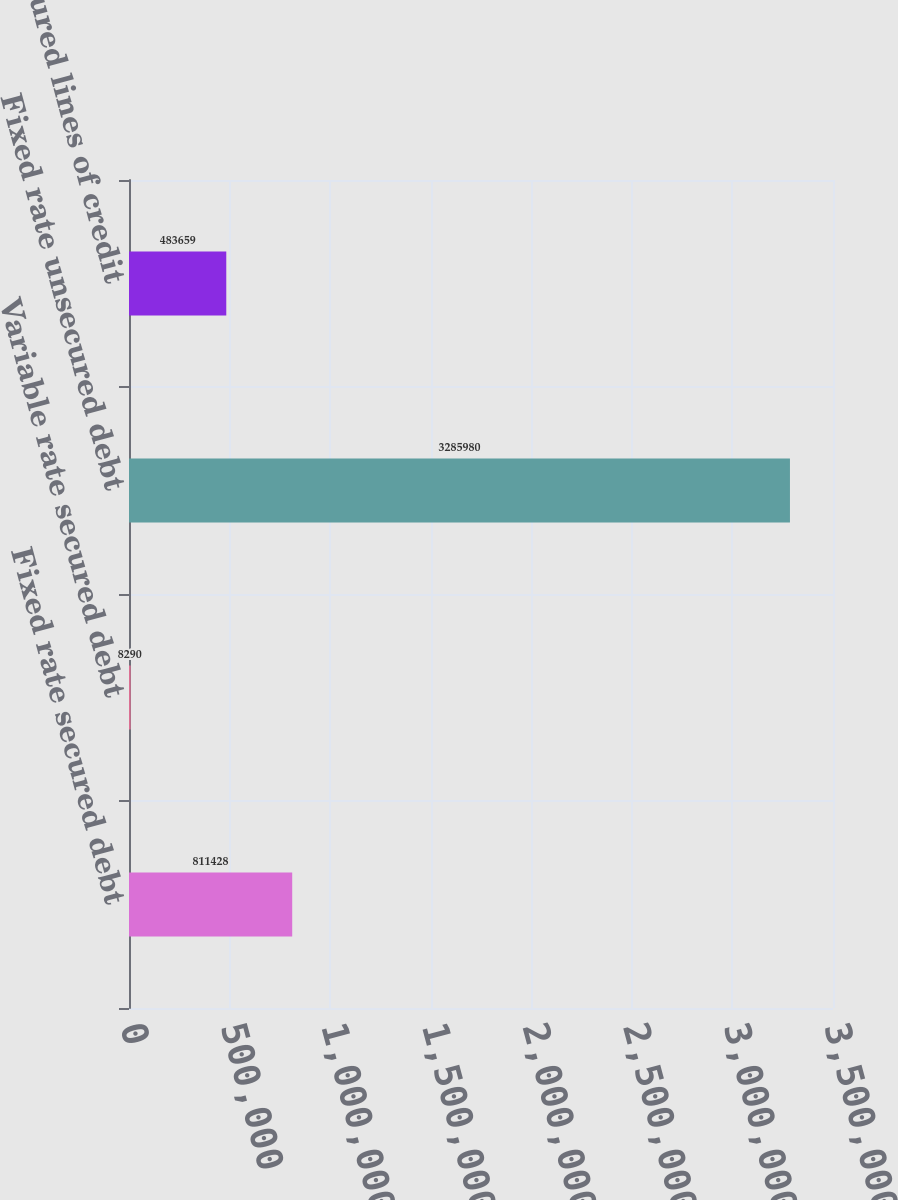<chart> <loc_0><loc_0><loc_500><loc_500><bar_chart><fcel>Fixed rate secured debt<fcel>Variable rate secured debt<fcel>Fixed rate unsecured debt<fcel>Unsecured lines of credit<nl><fcel>811428<fcel>8290<fcel>3.28598e+06<fcel>483659<nl></chart> 